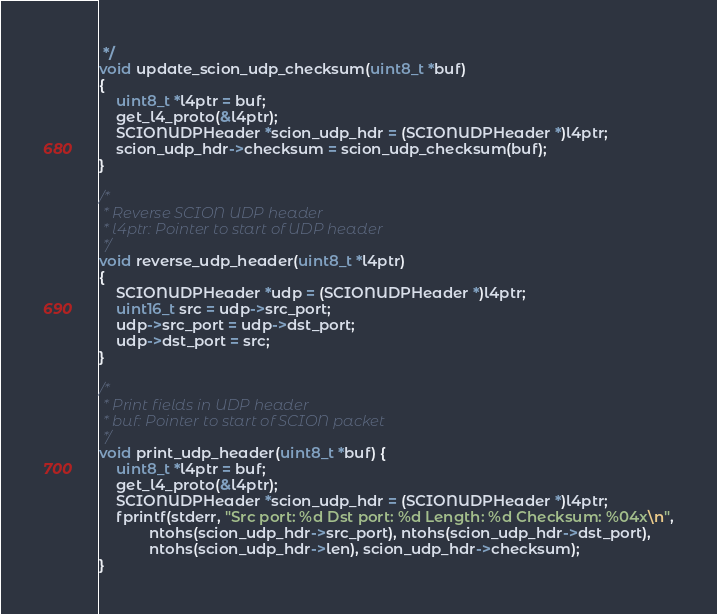<code> <loc_0><loc_0><loc_500><loc_500><_C_> */
void update_scion_udp_checksum(uint8_t *buf)
{
    uint8_t *l4ptr = buf;
    get_l4_proto(&l4ptr);
    SCIONUDPHeader *scion_udp_hdr = (SCIONUDPHeader *)l4ptr;
    scion_udp_hdr->checksum = scion_udp_checksum(buf);
}

/*
 * Reverse SCION UDP header
 * l4ptr: Pointer to start of UDP header
 */
void reverse_udp_header(uint8_t *l4ptr)
{
    SCIONUDPHeader *udp = (SCIONUDPHeader *)l4ptr;
    uint16_t src = udp->src_port;
    udp->src_port = udp->dst_port;
    udp->dst_port = src;
}

/*
 * Print fields in UDP header
 * buf: Pointer to start of SCION packet
 */
void print_udp_header(uint8_t *buf) {
    uint8_t *l4ptr = buf;
    get_l4_proto(&l4ptr);
    SCIONUDPHeader *scion_udp_hdr = (SCIONUDPHeader *)l4ptr;
    fprintf(stderr, "Src port: %d Dst port: %d Length: %d Checksum: %04x\n",
            ntohs(scion_udp_hdr->src_port), ntohs(scion_udp_hdr->dst_port),
            ntohs(scion_udp_hdr->len), scion_udp_hdr->checksum);
}
</code> 